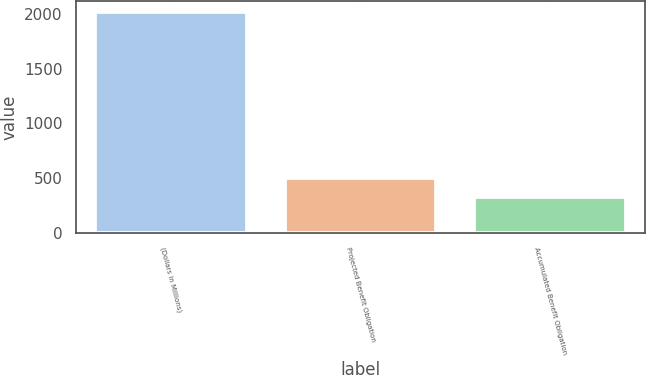Convert chart to OTSL. <chart><loc_0><loc_0><loc_500><loc_500><bar_chart><fcel>(Dollars in Millions)<fcel>Projected Benefit Obligation<fcel>Accumulated Benefit Obligation<nl><fcel>2016<fcel>497.7<fcel>329<nl></chart> 